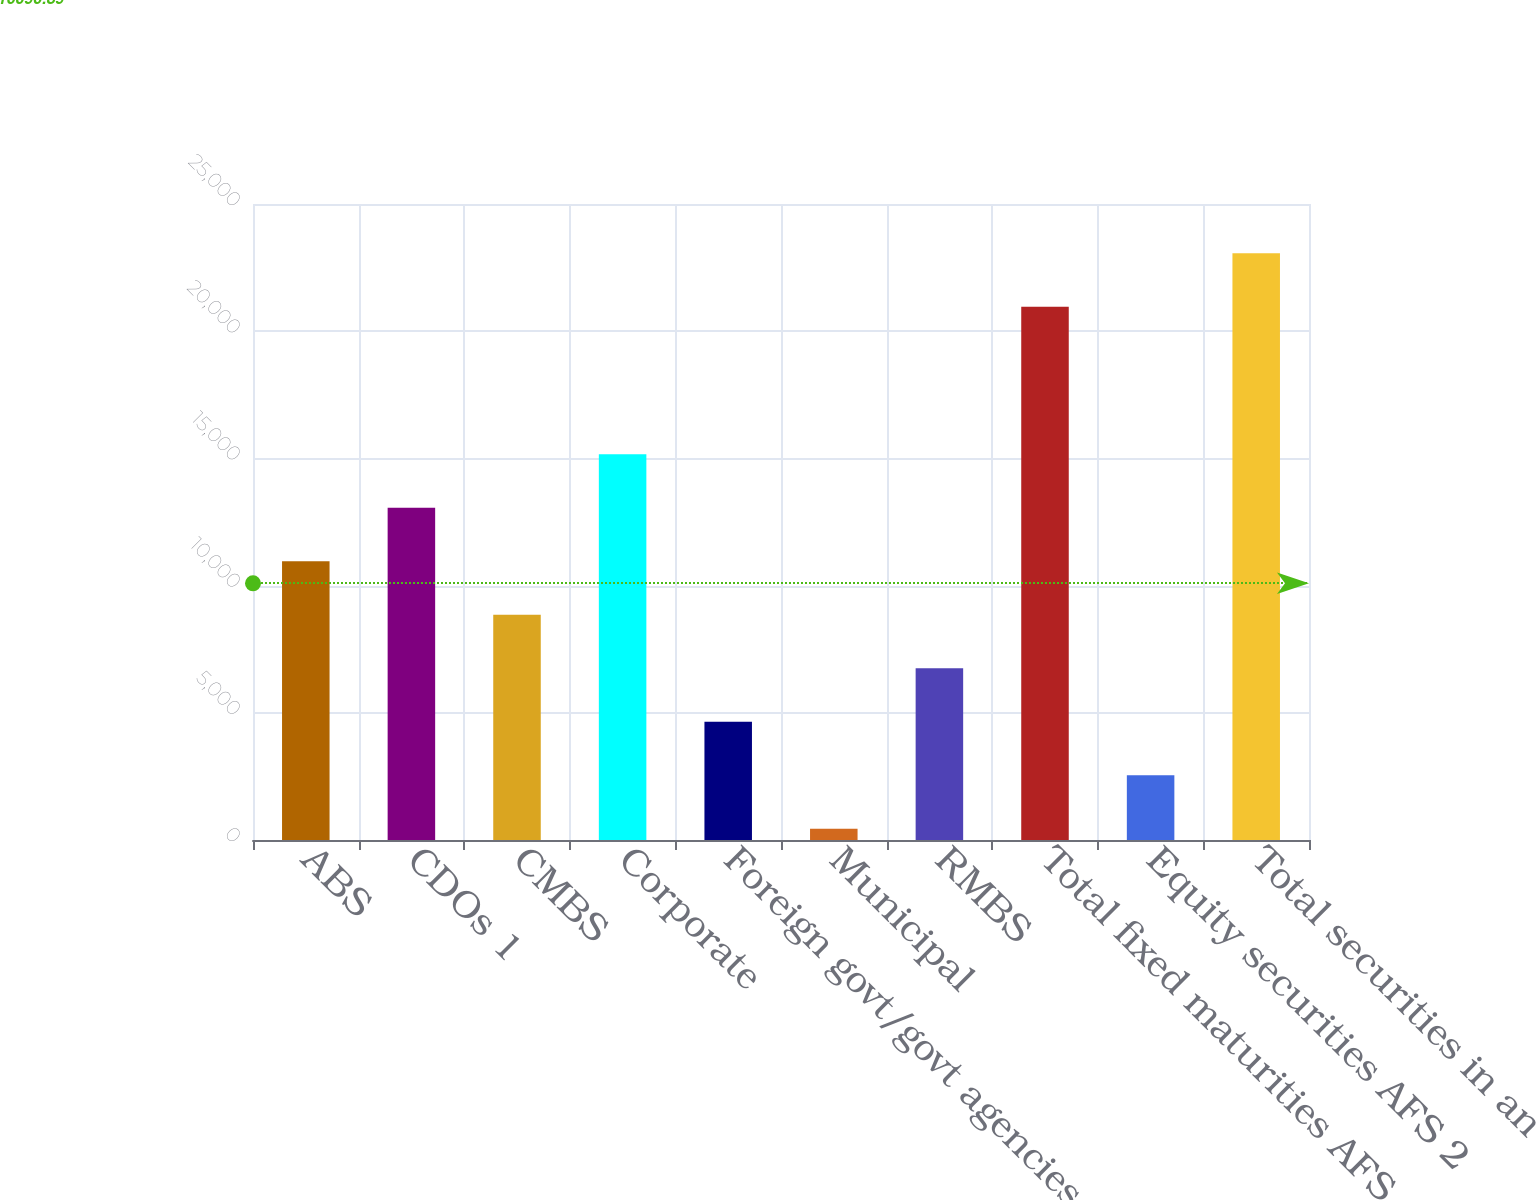Convert chart to OTSL. <chart><loc_0><loc_0><loc_500><loc_500><bar_chart><fcel>ABS<fcel>CDOs 1<fcel>CMBS<fcel>Corporate<fcel>Foreign govt/govt agencies<fcel>Municipal<fcel>RMBS<fcel>Total fixed maturities AFS<fcel>Equity securities AFS 2<fcel>Total securities in an<nl><fcel>10956<fcel>13057.8<fcel>8854.2<fcel>15159.6<fcel>4650.6<fcel>447<fcel>6752.4<fcel>20964<fcel>2548.8<fcel>23065.8<nl></chart> 